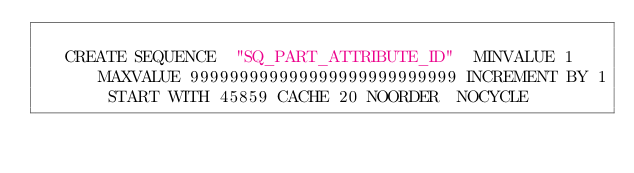Convert code to text. <code><loc_0><loc_0><loc_500><loc_500><_SQL_>
   CREATE SEQUENCE  "SQ_PART_ATTRIBUTE_ID"  MINVALUE 1 MAXVALUE 999999999999999999999999999 INCREMENT BY 1 START WITH 45859 CACHE 20 NOORDER  NOCYCLE </code> 